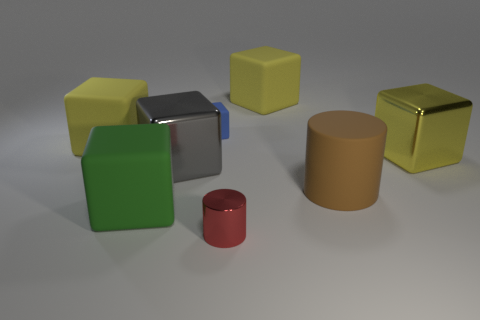Subtract all green spheres. How many yellow cubes are left? 3 Subtract all green blocks. How many blocks are left? 5 Subtract all green cubes. How many cubes are left? 5 Subtract all purple blocks. Subtract all purple balls. How many blocks are left? 6 Add 1 green matte cylinders. How many objects exist? 9 Subtract all cubes. How many objects are left? 2 Add 3 big green matte blocks. How many big green matte blocks are left? 4 Add 3 purple metal spheres. How many purple metal spheres exist? 3 Subtract 0 blue cylinders. How many objects are left? 8 Subtract all large matte balls. Subtract all red cylinders. How many objects are left? 7 